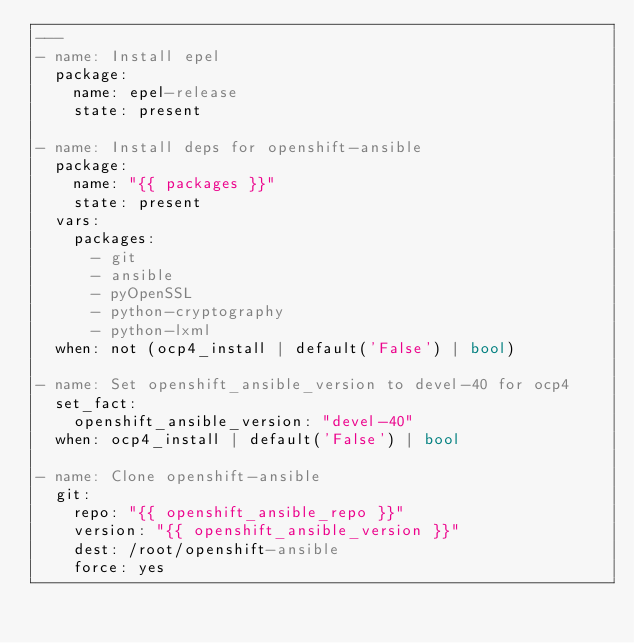<code> <loc_0><loc_0><loc_500><loc_500><_YAML_>---
- name: Install epel
  package:
    name: epel-release
    state: present

- name: Install deps for openshift-ansible
  package:
    name: "{{ packages }}"
    state: present
  vars:
    packages:
      - git
      - ansible
      - pyOpenSSL
      - python-cryptography
      - python-lxml
  when: not (ocp4_install | default('False') | bool)

- name: Set openshift_ansible_version to devel-40 for ocp4
  set_fact:
    openshift_ansible_version: "devel-40"
  when: ocp4_install | default('False') | bool

- name: Clone openshift-ansible
  git:
    repo: "{{ openshift_ansible_repo }}"
    version: "{{ openshift_ansible_version }}"
    dest: /root/openshift-ansible
    force: yes
</code> 